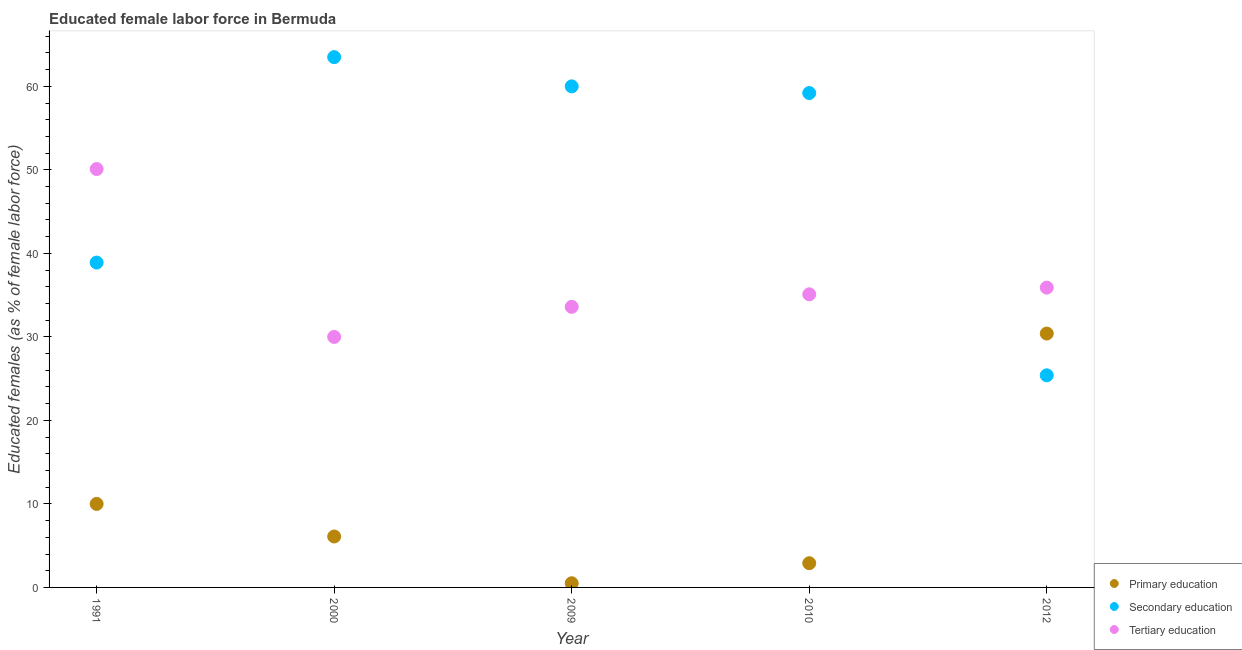What is the percentage of female labor force who received tertiary education in 1991?
Your response must be concise. 50.1. Across all years, what is the maximum percentage of female labor force who received tertiary education?
Ensure brevity in your answer.  50.1. Across all years, what is the minimum percentage of female labor force who received secondary education?
Your response must be concise. 25.4. In which year was the percentage of female labor force who received primary education minimum?
Your answer should be very brief. 2009. What is the total percentage of female labor force who received secondary education in the graph?
Provide a short and direct response. 247. What is the difference between the percentage of female labor force who received secondary education in 1991 and that in 2012?
Make the answer very short. 13.5. What is the difference between the percentage of female labor force who received primary education in 2000 and the percentage of female labor force who received secondary education in 1991?
Give a very brief answer. -32.8. What is the average percentage of female labor force who received primary education per year?
Your answer should be compact. 9.98. In the year 2012, what is the difference between the percentage of female labor force who received secondary education and percentage of female labor force who received tertiary education?
Make the answer very short. -10.5. What is the ratio of the percentage of female labor force who received secondary education in 2000 to that in 2010?
Your answer should be compact. 1.07. Is the percentage of female labor force who received tertiary education in 1991 less than that in 2012?
Offer a terse response. No. What is the difference between the highest and the second highest percentage of female labor force who received tertiary education?
Your answer should be compact. 14.2. What is the difference between the highest and the lowest percentage of female labor force who received tertiary education?
Your answer should be compact. 20.1. In how many years, is the percentage of female labor force who received secondary education greater than the average percentage of female labor force who received secondary education taken over all years?
Provide a short and direct response. 3. Is the sum of the percentage of female labor force who received primary education in 1991 and 2009 greater than the maximum percentage of female labor force who received tertiary education across all years?
Provide a succinct answer. No. Is the percentage of female labor force who received tertiary education strictly greater than the percentage of female labor force who received secondary education over the years?
Give a very brief answer. No. How many dotlines are there?
Your response must be concise. 3. Are the values on the major ticks of Y-axis written in scientific E-notation?
Provide a short and direct response. No. Does the graph contain any zero values?
Provide a succinct answer. No. Does the graph contain grids?
Make the answer very short. No. Where does the legend appear in the graph?
Your answer should be very brief. Bottom right. How are the legend labels stacked?
Make the answer very short. Vertical. What is the title of the graph?
Your answer should be very brief. Educated female labor force in Bermuda. Does "Central government" appear as one of the legend labels in the graph?
Make the answer very short. No. What is the label or title of the Y-axis?
Give a very brief answer. Educated females (as % of female labor force). What is the Educated females (as % of female labor force) of Primary education in 1991?
Your answer should be compact. 10. What is the Educated females (as % of female labor force) of Secondary education in 1991?
Make the answer very short. 38.9. What is the Educated females (as % of female labor force) of Tertiary education in 1991?
Keep it short and to the point. 50.1. What is the Educated females (as % of female labor force) in Primary education in 2000?
Your answer should be very brief. 6.1. What is the Educated females (as % of female labor force) in Secondary education in 2000?
Provide a succinct answer. 63.5. What is the Educated females (as % of female labor force) in Tertiary education in 2000?
Your answer should be compact. 30. What is the Educated females (as % of female labor force) in Secondary education in 2009?
Your answer should be very brief. 60. What is the Educated females (as % of female labor force) of Tertiary education in 2009?
Make the answer very short. 33.6. What is the Educated females (as % of female labor force) of Primary education in 2010?
Your response must be concise. 2.9. What is the Educated females (as % of female labor force) in Secondary education in 2010?
Provide a short and direct response. 59.2. What is the Educated females (as % of female labor force) in Tertiary education in 2010?
Provide a short and direct response. 35.1. What is the Educated females (as % of female labor force) in Primary education in 2012?
Make the answer very short. 30.4. What is the Educated females (as % of female labor force) of Secondary education in 2012?
Your response must be concise. 25.4. What is the Educated females (as % of female labor force) of Tertiary education in 2012?
Your response must be concise. 35.9. Across all years, what is the maximum Educated females (as % of female labor force) in Primary education?
Provide a short and direct response. 30.4. Across all years, what is the maximum Educated females (as % of female labor force) of Secondary education?
Provide a succinct answer. 63.5. Across all years, what is the maximum Educated females (as % of female labor force) in Tertiary education?
Offer a terse response. 50.1. Across all years, what is the minimum Educated females (as % of female labor force) in Secondary education?
Give a very brief answer. 25.4. What is the total Educated females (as % of female labor force) of Primary education in the graph?
Your response must be concise. 49.9. What is the total Educated females (as % of female labor force) in Secondary education in the graph?
Give a very brief answer. 247. What is the total Educated females (as % of female labor force) of Tertiary education in the graph?
Offer a terse response. 184.7. What is the difference between the Educated females (as % of female labor force) in Primary education in 1991 and that in 2000?
Ensure brevity in your answer.  3.9. What is the difference between the Educated females (as % of female labor force) in Secondary education in 1991 and that in 2000?
Make the answer very short. -24.6. What is the difference between the Educated females (as % of female labor force) in Tertiary education in 1991 and that in 2000?
Provide a succinct answer. 20.1. What is the difference between the Educated females (as % of female labor force) in Secondary education in 1991 and that in 2009?
Keep it short and to the point. -21.1. What is the difference between the Educated females (as % of female labor force) of Primary education in 1991 and that in 2010?
Provide a short and direct response. 7.1. What is the difference between the Educated females (as % of female labor force) of Secondary education in 1991 and that in 2010?
Offer a very short reply. -20.3. What is the difference between the Educated females (as % of female labor force) of Primary education in 1991 and that in 2012?
Your answer should be compact. -20.4. What is the difference between the Educated females (as % of female labor force) in Secondary education in 1991 and that in 2012?
Provide a succinct answer. 13.5. What is the difference between the Educated females (as % of female labor force) in Tertiary education in 1991 and that in 2012?
Make the answer very short. 14.2. What is the difference between the Educated females (as % of female labor force) of Secondary education in 2000 and that in 2009?
Offer a very short reply. 3.5. What is the difference between the Educated females (as % of female labor force) of Primary education in 2000 and that in 2010?
Give a very brief answer. 3.2. What is the difference between the Educated females (as % of female labor force) in Secondary education in 2000 and that in 2010?
Offer a very short reply. 4.3. What is the difference between the Educated females (as % of female labor force) of Tertiary education in 2000 and that in 2010?
Provide a short and direct response. -5.1. What is the difference between the Educated females (as % of female labor force) in Primary education in 2000 and that in 2012?
Offer a very short reply. -24.3. What is the difference between the Educated females (as % of female labor force) in Secondary education in 2000 and that in 2012?
Offer a terse response. 38.1. What is the difference between the Educated females (as % of female labor force) in Tertiary education in 2000 and that in 2012?
Ensure brevity in your answer.  -5.9. What is the difference between the Educated females (as % of female labor force) in Primary education in 2009 and that in 2012?
Provide a short and direct response. -29.9. What is the difference between the Educated females (as % of female labor force) in Secondary education in 2009 and that in 2012?
Make the answer very short. 34.6. What is the difference between the Educated females (as % of female labor force) in Tertiary education in 2009 and that in 2012?
Make the answer very short. -2.3. What is the difference between the Educated females (as % of female labor force) of Primary education in 2010 and that in 2012?
Keep it short and to the point. -27.5. What is the difference between the Educated females (as % of female labor force) in Secondary education in 2010 and that in 2012?
Offer a terse response. 33.8. What is the difference between the Educated females (as % of female labor force) of Tertiary education in 2010 and that in 2012?
Your answer should be compact. -0.8. What is the difference between the Educated females (as % of female labor force) of Primary education in 1991 and the Educated females (as % of female labor force) of Secondary education in 2000?
Keep it short and to the point. -53.5. What is the difference between the Educated females (as % of female labor force) of Primary education in 1991 and the Educated females (as % of female labor force) of Secondary education in 2009?
Give a very brief answer. -50. What is the difference between the Educated females (as % of female labor force) of Primary education in 1991 and the Educated females (as % of female labor force) of Tertiary education in 2009?
Make the answer very short. -23.6. What is the difference between the Educated females (as % of female labor force) in Primary education in 1991 and the Educated females (as % of female labor force) in Secondary education in 2010?
Offer a terse response. -49.2. What is the difference between the Educated females (as % of female labor force) in Primary education in 1991 and the Educated females (as % of female labor force) in Tertiary education in 2010?
Provide a succinct answer. -25.1. What is the difference between the Educated females (as % of female labor force) of Secondary education in 1991 and the Educated females (as % of female labor force) of Tertiary education in 2010?
Your answer should be very brief. 3.8. What is the difference between the Educated females (as % of female labor force) of Primary education in 1991 and the Educated females (as % of female labor force) of Secondary education in 2012?
Offer a terse response. -15.4. What is the difference between the Educated females (as % of female labor force) of Primary education in 1991 and the Educated females (as % of female labor force) of Tertiary education in 2012?
Make the answer very short. -25.9. What is the difference between the Educated females (as % of female labor force) of Primary education in 2000 and the Educated females (as % of female labor force) of Secondary education in 2009?
Provide a succinct answer. -53.9. What is the difference between the Educated females (as % of female labor force) in Primary education in 2000 and the Educated females (as % of female labor force) in Tertiary education in 2009?
Make the answer very short. -27.5. What is the difference between the Educated females (as % of female labor force) of Secondary education in 2000 and the Educated females (as % of female labor force) of Tertiary education in 2009?
Offer a terse response. 29.9. What is the difference between the Educated females (as % of female labor force) in Primary education in 2000 and the Educated females (as % of female labor force) in Secondary education in 2010?
Keep it short and to the point. -53.1. What is the difference between the Educated females (as % of female labor force) in Primary education in 2000 and the Educated females (as % of female labor force) in Tertiary education in 2010?
Give a very brief answer. -29. What is the difference between the Educated females (as % of female labor force) of Secondary education in 2000 and the Educated females (as % of female labor force) of Tertiary education in 2010?
Offer a terse response. 28.4. What is the difference between the Educated females (as % of female labor force) in Primary education in 2000 and the Educated females (as % of female labor force) in Secondary education in 2012?
Your answer should be compact. -19.3. What is the difference between the Educated females (as % of female labor force) of Primary education in 2000 and the Educated females (as % of female labor force) of Tertiary education in 2012?
Give a very brief answer. -29.8. What is the difference between the Educated females (as % of female labor force) in Secondary education in 2000 and the Educated females (as % of female labor force) in Tertiary education in 2012?
Your answer should be compact. 27.6. What is the difference between the Educated females (as % of female labor force) in Primary education in 2009 and the Educated females (as % of female labor force) in Secondary education in 2010?
Offer a terse response. -58.7. What is the difference between the Educated females (as % of female labor force) of Primary education in 2009 and the Educated females (as % of female labor force) of Tertiary education in 2010?
Keep it short and to the point. -34.6. What is the difference between the Educated females (as % of female labor force) in Secondary education in 2009 and the Educated females (as % of female labor force) in Tertiary education in 2010?
Provide a succinct answer. 24.9. What is the difference between the Educated females (as % of female labor force) in Primary education in 2009 and the Educated females (as % of female labor force) in Secondary education in 2012?
Provide a short and direct response. -24.9. What is the difference between the Educated females (as % of female labor force) in Primary education in 2009 and the Educated females (as % of female labor force) in Tertiary education in 2012?
Provide a succinct answer. -35.4. What is the difference between the Educated females (as % of female labor force) of Secondary education in 2009 and the Educated females (as % of female labor force) of Tertiary education in 2012?
Your answer should be very brief. 24.1. What is the difference between the Educated females (as % of female labor force) of Primary education in 2010 and the Educated females (as % of female labor force) of Secondary education in 2012?
Your answer should be very brief. -22.5. What is the difference between the Educated females (as % of female labor force) in Primary education in 2010 and the Educated females (as % of female labor force) in Tertiary education in 2012?
Make the answer very short. -33. What is the difference between the Educated females (as % of female labor force) of Secondary education in 2010 and the Educated females (as % of female labor force) of Tertiary education in 2012?
Offer a terse response. 23.3. What is the average Educated females (as % of female labor force) in Primary education per year?
Offer a very short reply. 9.98. What is the average Educated females (as % of female labor force) in Secondary education per year?
Provide a succinct answer. 49.4. What is the average Educated females (as % of female labor force) in Tertiary education per year?
Offer a very short reply. 36.94. In the year 1991, what is the difference between the Educated females (as % of female labor force) in Primary education and Educated females (as % of female labor force) in Secondary education?
Your answer should be very brief. -28.9. In the year 1991, what is the difference between the Educated females (as % of female labor force) of Primary education and Educated females (as % of female labor force) of Tertiary education?
Offer a terse response. -40.1. In the year 1991, what is the difference between the Educated females (as % of female labor force) in Secondary education and Educated females (as % of female labor force) in Tertiary education?
Provide a short and direct response. -11.2. In the year 2000, what is the difference between the Educated females (as % of female labor force) in Primary education and Educated females (as % of female labor force) in Secondary education?
Your answer should be very brief. -57.4. In the year 2000, what is the difference between the Educated females (as % of female labor force) in Primary education and Educated females (as % of female labor force) in Tertiary education?
Ensure brevity in your answer.  -23.9. In the year 2000, what is the difference between the Educated females (as % of female labor force) of Secondary education and Educated females (as % of female labor force) of Tertiary education?
Your answer should be compact. 33.5. In the year 2009, what is the difference between the Educated females (as % of female labor force) in Primary education and Educated females (as % of female labor force) in Secondary education?
Your answer should be very brief. -59.5. In the year 2009, what is the difference between the Educated females (as % of female labor force) in Primary education and Educated females (as % of female labor force) in Tertiary education?
Your response must be concise. -33.1. In the year 2009, what is the difference between the Educated females (as % of female labor force) in Secondary education and Educated females (as % of female labor force) in Tertiary education?
Offer a terse response. 26.4. In the year 2010, what is the difference between the Educated females (as % of female labor force) in Primary education and Educated females (as % of female labor force) in Secondary education?
Your response must be concise. -56.3. In the year 2010, what is the difference between the Educated females (as % of female labor force) of Primary education and Educated females (as % of female labor force) of Tertiary education?
Your answer should be very brief. -32.2. In the year 2010, what is the difference between the Educated females (as % of female labor force) in Secondary education and Educated females (as % of female labor force) in Tertiary education?
Your response must be concise. 24.1. In the year 2012, what is the difference between the Educated females (as % of female labor force) of Primary education and Educated females (as % of female labor force) of Secondary education?
Offer a terse response. 5. In the year 2012, what is the difference between the Educated females (as % of female labor force) of Primary education and Educated females (as % of female labor force) of Tertiary education?
Provide a succinct answer. -5.5. In the year 2012, what is the difference between the Educated females (as % of female labor force) in Secondary education and Educated females (as % of female labor force) in Tertiary education?
Your answer should be very brief. -10.5. What is the ratio of the Educated females (as % of female labor force) of Primary education in 1991 to that in 2000?
Your response must be concise. 1.64. What is the ratio of the Educated females (as % of female labor force) in Secondary education in 1991 to that in 2000?
Give a very brief answer. 0.61. What is the ratio of the Educated females (as % of female labor force) of Tertiary education in 1991 to that in 2000?
Provide a succinct answer. 1.67. What is the ratio of the Educated females (as % of female labor force) of Secondary education in 1991 to that in 2009?
Ensure brevity in your answer.  0.65. What is the ratio of the Educated females (as % of female labor force) of Tertiary education in 1991 to that in 2009?
Your answer should be compact. 1.49. What is the ratio of the Educated females (as % of female labor force) in Primary education in 1991 to that in 2010?
Ensure brevity in your answer.  3.45. What is the ratio of the Educated females (as % of female labor force) in Secondary education in 1991 to that in 2010?
Make the answer very short. 0.66. What is the ratio of the Educated females (as % of female labor force) of Tertiary education in 1991 to that in 2010?
Make the answer very short. 1.43. What is the ratio of the Educated females (as % of female labor force) in Primary education in 1991 to that in 2012?
Offer a terse response. 0.33. What is the ratio of the Educated females (as % of female labor force) in Secondary education in 1991 to that in 2012?
Provide a short and direct response. 1.53. What is the ratio of the Educated females (as % of female labor force) of Tertiary education in 1991 to that in 2012?
Ensure brevity in your answer.  1.4. What is the ratio of the Educated females (as % of female labor force) in Primary education in 2000 to that in 2009?
Give a very brief answer. 12.2. What is the ratio of the Educated females (as % of female labor force) of Secondary education in 2000 to that in 2009?
Ensure brevity in your answer.  1.06. What is the ratio of the Educated females (as % of female labor force) in Tertiary education in 2000 to that in 2009?
Offer a very short reply. 0.89. What is the ratio of the Educated females (as % of female labor force) of Primary education in 2000 to that in 2010?
Offer a terse response. 2.1. What is the ratio of the Educated females (as % of female labor force) of Secondary education in 2000 to that in 2010?
Your answer should be compact. 1.07. What is the ratio of the Educated females (as % of female labor force) of Tertiary education in 2000 to that in 2010?
Offer a very short reply. 0.85. What is the ratio of the Educated females (as % of female labor force) in Primary education in 2000 to that in 2012?
Provide a short and direct response. 0.2. What is the ratio of the Educated females (as % of female labor force) of Secondary education in 2000 to that in 2012?
Offer a terse response. 2.5. What is the ratio of the Educated females (as % of female labor force) of Tertiary education in 2000 to that in 2012?
Make the answer very short. 0.84. What is the ratio of the Educated females (as % of female labor force) of Primary education in 2009 to that in 2010?
Provide a short and direct response. 0.17. What is the ratio of the Educated females (as % of female labor force) in Secondary education in 2009 to that in 2010?
Your answer should be very brief. 1.01. What is the ratio of the Educated females (as % of female labor force) of Tertiary education in 2009 to that in 2010?
Ensure brevity in your answer.  0.96. What is the ratio of the Educated females (as % of female labor force) of Primary education in 2009 to that in 2012?
Your response must be concise. 0.02. What is the ratio of the Educated females (as % of female labor force) in Secondary education in 2009 to that in 2012?
Your response must be concise. 2.36. What is the ratio of the Educated females (as % of female labor force) of Tertiary education in 2009 to that in 2012?
Ensure brevity in your answer.  0.94. What is the ratio of the Educated females (as % of female labor force) in Primary education in 2010 to that in 2012?
Your answer should be compact. 0.1. What is the ratio of the Educated females (as % of female labor force) in Secondary education in 2010 to that in 2012?
Your response must be concise. 2.33. What is the ratio of the Educated females (as % of female labor force) of Tertiary education in 2010 to that in 2012?
Offer a very short reply. 0.98. What is the difference between the highest and the second highest Educated females (as % of female labor force) of Primary education?
Keep it short and to the point. 20.4. What is the difference between the highest and the second highest Educated females (as % of female labor force) of Secondary education?
Keep it short and to the point. 3.5. What is the difference between the highest and the second highest Educated females (as % of female labor force) in Tertiary education?
Offer a terse response. 14.2. What is the difference between the highest and the lowest Educated females (as % of female labor force) of Primary education?
Your answer should be very brief. 29.9. What is the difference between the highest and the lowest Educated females (as % of female labor force) of Secondary education?
Your answer should be compact. 38.1. What is the difference between the highest and the lowest Educated females (as % of female labor force) in Tertiary education?
Your answer should be compact. 20.1. 